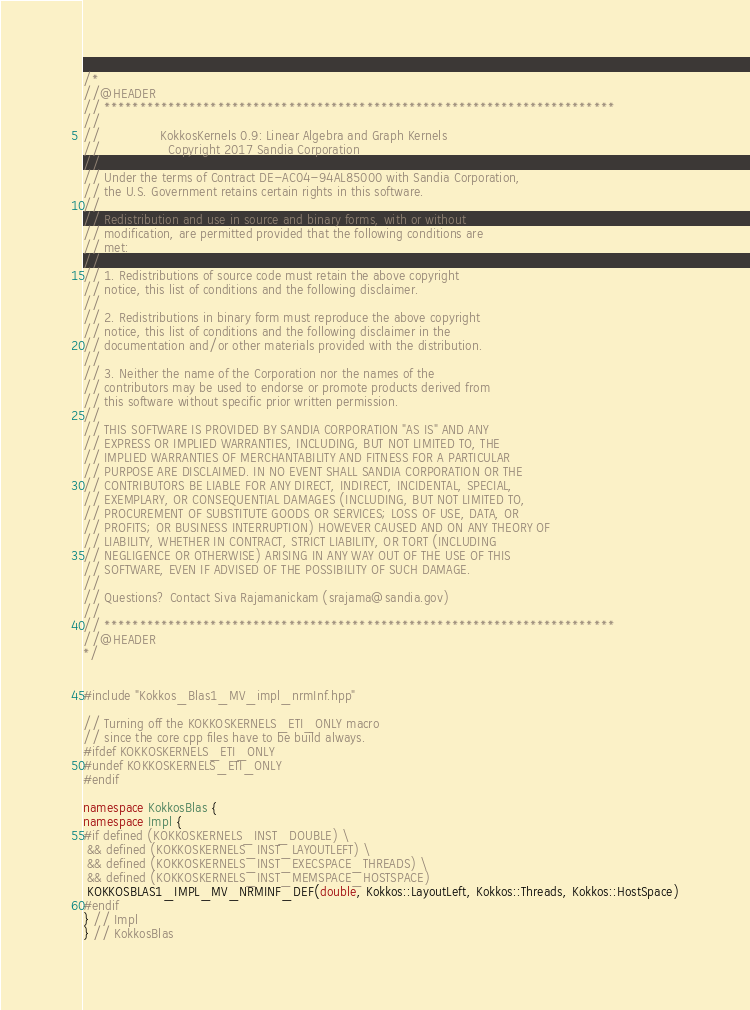<code> <loc_0><loc_0><loc_500><loc_500><_C++_>/*
//@HEADER
// ************************************************************************
//
//               KokkosKernels 0.9: Linear Algebra and Graph Kernels
//                 Copyright 2017 Sandia Corporation
//
// Under the terms of Contract DE-AC04-94AL85000 with Sandia Corporation,
// the U.S. Government retains certain rights in this software.
//
// Redistribution and use in source and binary forms, with or without
// modification, are permitted provided that the following conditions are
// met:
//
// 1. Redistributions of source code must retain the above copyright
// notice, this list of conditions and the following disclaimer.
//
// 2. Redistributions in binary form must reproduce the above copyright
// notice, this list of conditions and the following disclaimer in the
// documentation and/or other materials provided with the distribution.
//
// 3. Neither the name of the Corporation nor the names of the
// contributors may be used to endorse or promote products derived from
// this software without specific prior written permission.
//
// THIS SOFTWARE IS PROVIDED BY SANDIA CORPORATION "AS IS" AND ANY
// EXPRESS OR IMPLIED WARRANTIES, INCLUDING, BUT NOT LIMITED TO, THE
// IMPLIED WARRANTIES OF MERCHANTABILITY AND FITNESS FOR A PARTICULAR
// PURPOSE ARE DISCLAIMED. IN NO EVENT SHALL SANDIA CORPORATION OR THE
// CONTRIBUTORS BE LIABLE FOR ANY DIRECT, INDIRECT, INCIDENTAL, SPECIAL,
// EXEMPLARY, OR CONSEQUENTIAL DAMAGES (INCLUDING, BUT NOT LIMITED TO,
// PROCUREMENT OF SUBSTITUTE GOODS OR SERVICES; LOSS OF USE, DATA, OR
// PROFITS; OR BUSINESS INTERRUPTION) HOWEVER CAUSED AND ON ANY THEORY OF
// LIABILITY, WHETHER IN CONTRACT, STRICT LIABILITY, OR TORT (INCLUDING
// NEGLIGENCE OR OTHERWISE) ARISING IN ANY WAY OUT OF THE USE OF THIS
// SOFTWARE, EVEN IF ADVISED OF THE POSSIBILITY OF SUCH DAMAGE.
//
// Questions? Contact Siva Rajamanickam (srajama@sandia.gov)
//
// ************************************************************************
//@HEADER
*/


#include "Kokkos_Blas1_MV_impl_nrmInf.hpp"

// Turning off the KOKKOSKERNELS_ETI_ONLY macro
// since the core cpp files have to be build always.
#ifdef KOKKOSKERNELS_ETI_ONLY
#undef KOKKOSKERNELS_ETI_ONLY
#endif

namespace KokkosBlas {
namespace Impl {
#if defined (KOKKOSKERNELS_INST_DOUBLE) \
 && defined (KOKKOSKERNELS_INST_LAYOUTLEFT) \
 && defined (KOKKOSKERNELS_INST_EXECSPACE_THREADS) \
 && defined (KOKKOSKERNELS_INST_MEMSPACE_HOSTSPACE)
 KOKKOSBLAS1_IMPL_MV_NRMINF_DEF(double, Kokkos::LayoutLeft, Kokkos::Threads, Kokkos::HostSpace)
#endif
} // Impl
} // KokkosBlas
</code> 